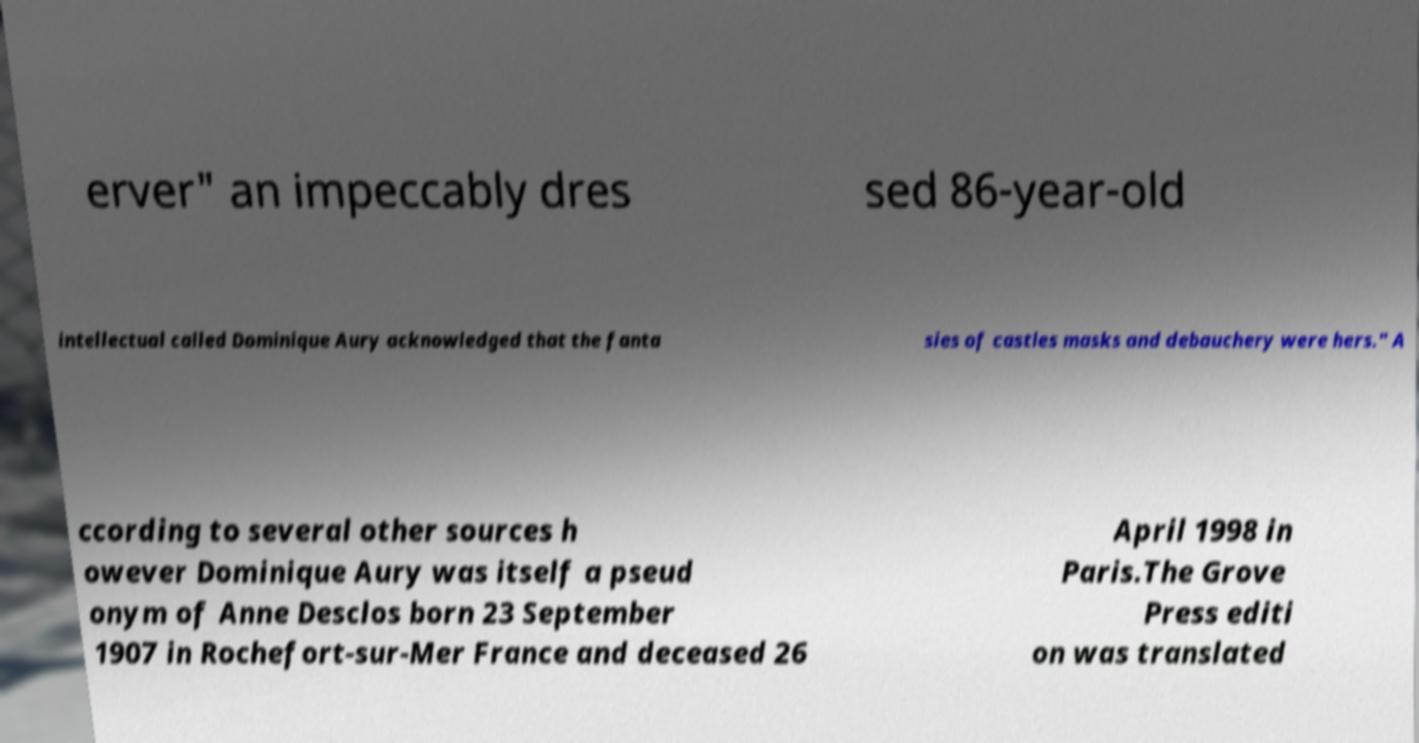Could you extract and type out the text from this image? erver" an impeccably dres sed 86-year-old intellectual called Dominique Aury acknowledged that the fanta sies of castles masks and debauchery were hers." A ccording to several other sources h owever Dominique Aury was itself a pseud onym of Anne Desclos born 23 September 1907 in Rochefort-sur-Mer France and deceased 26 April 1998 in Paris.The Grove Press editi on was translated 